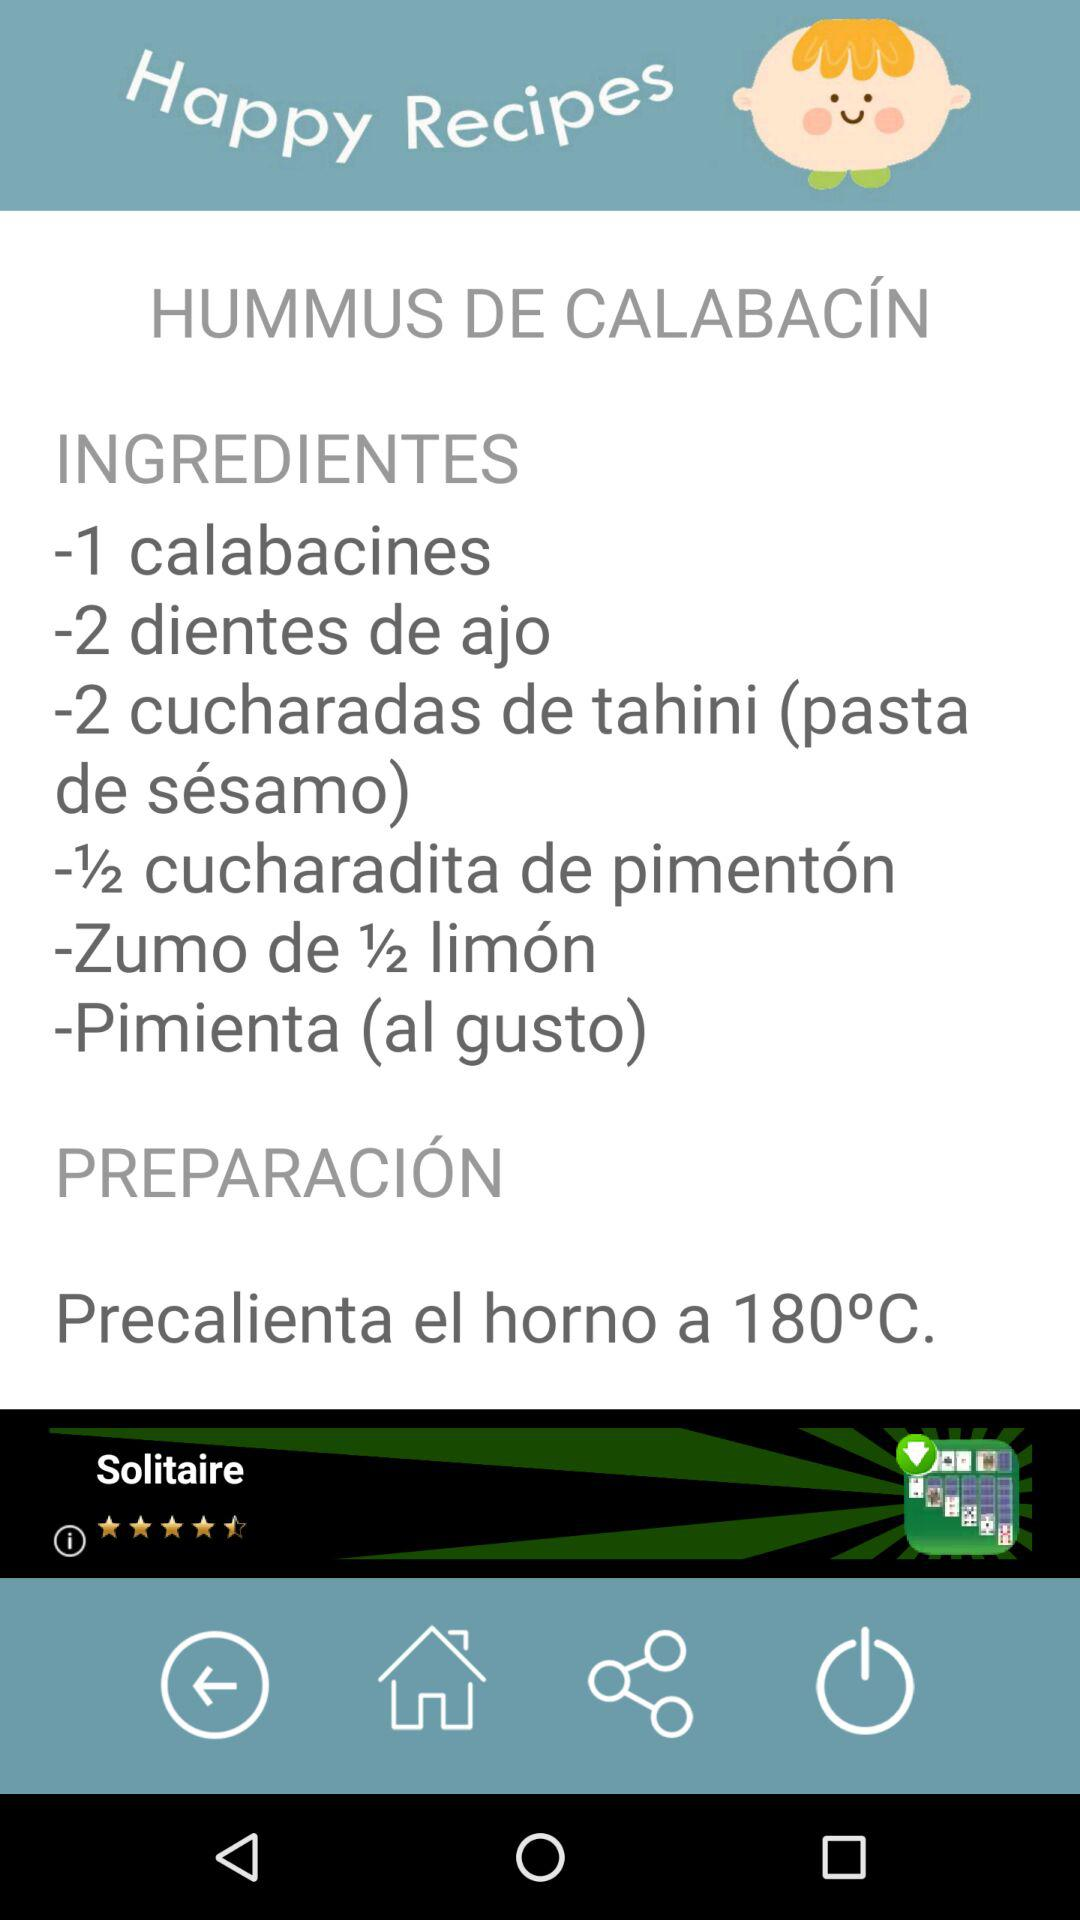How many ingredients are in the hummus recipe?
Answer the question using a single word or phrase. 6 